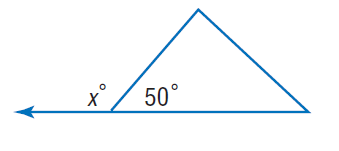Answer the mathemtical geometry problem and directly provide the correct option letter.
Question: Find x.
Choices: A: 40 B: 50 C: 130 D: 310 C 